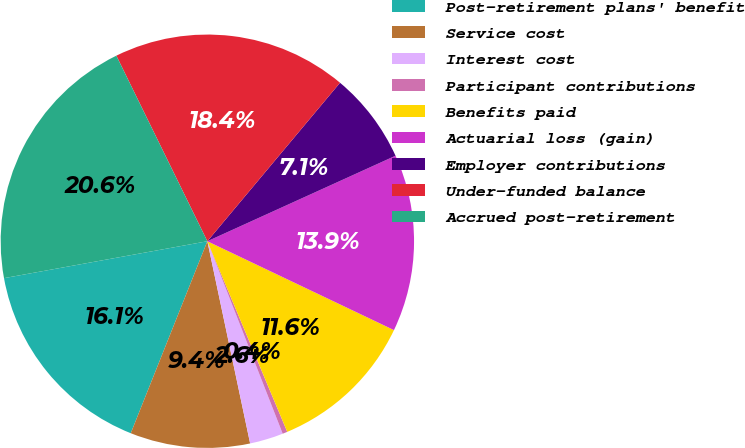Convert chart to OTSL. <chart><loc_0><loc_0><loc_500><loc_500><pie_chart><fcel>Post-retirement plans' benefit<fcel>Service cost<fcel>Interest cost<fcel>Participant contributions<fcel>Benefits paid<fcel>Actuarial loss (gain)<fcel>Employer contributions<fcel>Under-funded balance<fcel>Accrued post-retirement<nl><fcel>16.1%<fcel>9.36%<fcel>2.62%<fcel>0.38%<fcel>11.61%<fcel>13.86%<fcel>7.12%<fcel>18.35%<fcel>20.6%<nl></chart> 